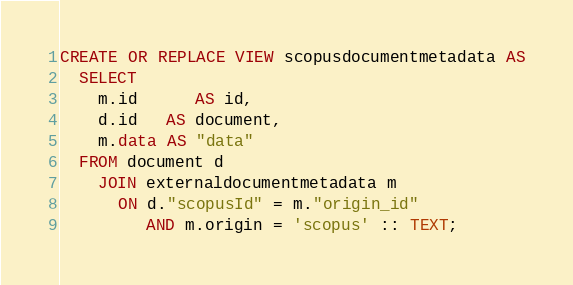<code> <loc_0><loc_0><loc_500><loc_500><_SQL_>CREATE OR REPLACE VIEW scopusdocumentmetadata AS
  SELECT
    m.id      AS id,
    d.id   AS document,
    m.data AS "data"
  FROM document d
    JOIN externaldocumentmetadata m
      ON d."scopusId" = m."origin_id"
         AND m.origin = 'scopus' :: TEXT;
</code> 